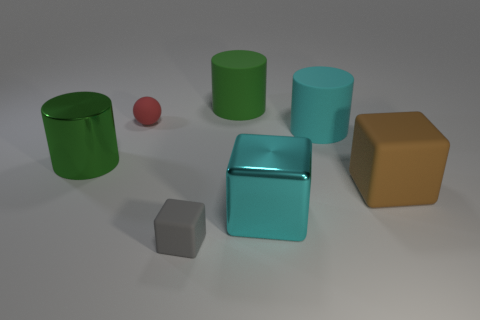Are there more big green objects than small gray cubes?
Keep it short and to the point. Yes. What number of other things are there of the same color as the small ball?
Make the answer very short. 0. How many large matte objects are left of the shiny thing that is right of the small red matte sphere?
Provide a succinct answer. 1. There is a big green metallic cylinder; are there any tiny gray objects on the left side of it?
Keep it short and to the point. No. There is a small thing that is behind the big block in front of the big brown rubber cube; what is its shape?
Provide a short and direct response. Sphere. Is the number of cyan rubber cylinders that are behind the green metallic cylinder less than the number of cylinders in front of the brown cube?
Offer a very short reply. No. The shiny object that is the same shape as the big brown rubber object is what color?
Offer a very short reply. Cyan. What number of objects are on the left side of the cyan cylinder and in front of the green matte object?
Offer a terse response. 4. Is the number of large cyan cylinders that are right of the big brown matte block greater than the number of metal objects that are on the right side of the small cube?
Provide a succinct answer. No. The red ball has what size?
Your answer should be compact. Small. 